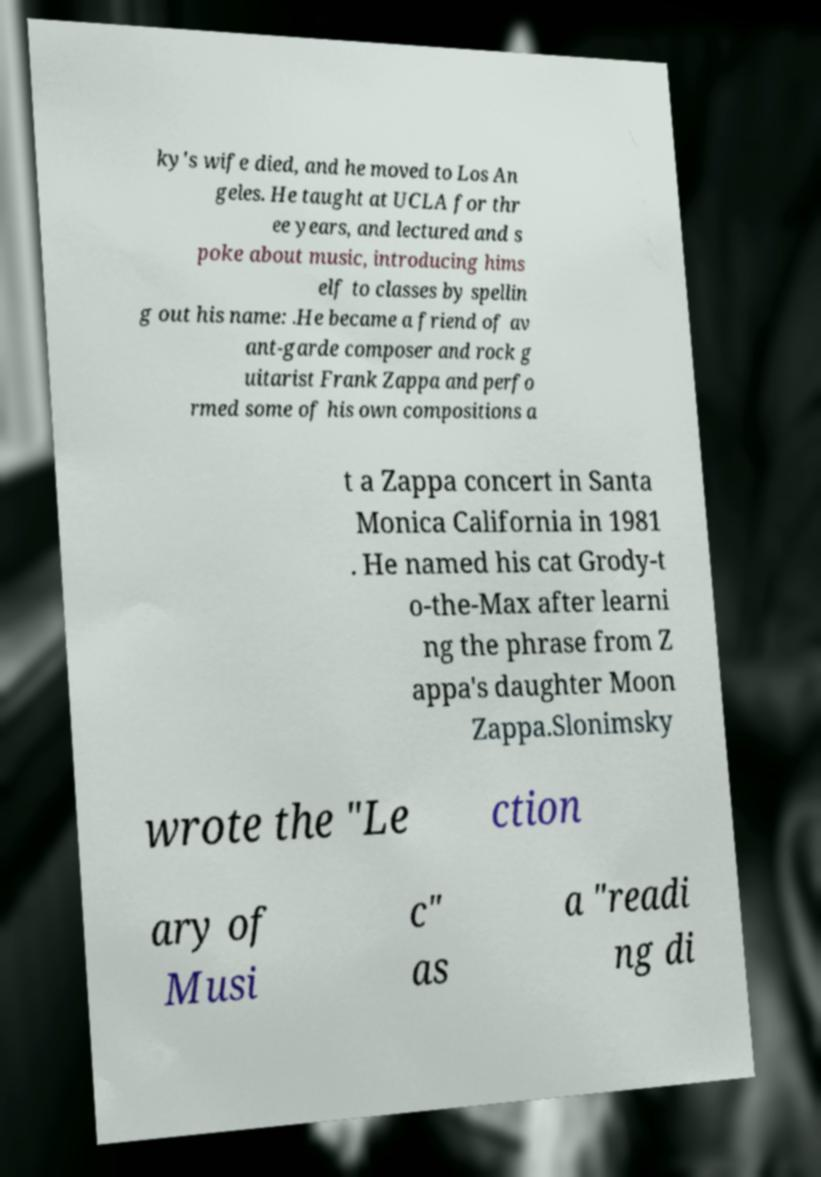Please read and relay the text visible in this image. What does it say? ky's wife died, and he moved to Los An geles. He taught at UCLA for thr ee years, and lectured and s poke about music, introducing hims elf to classes by spellin g out his name: .He became a friend of av ant-garde composer and rock g uitarist Frank Zappa and perfo rmed some of his own compositions a t a Zappa concert in Santa Monica California in 1981 . He named his cat Grody-t o-the-Max after learni ng the phrase from Z appa's daughter Moon Zappa.Slonimsky wrote the "Le ction ary of Musi c" as a "readi ng di 